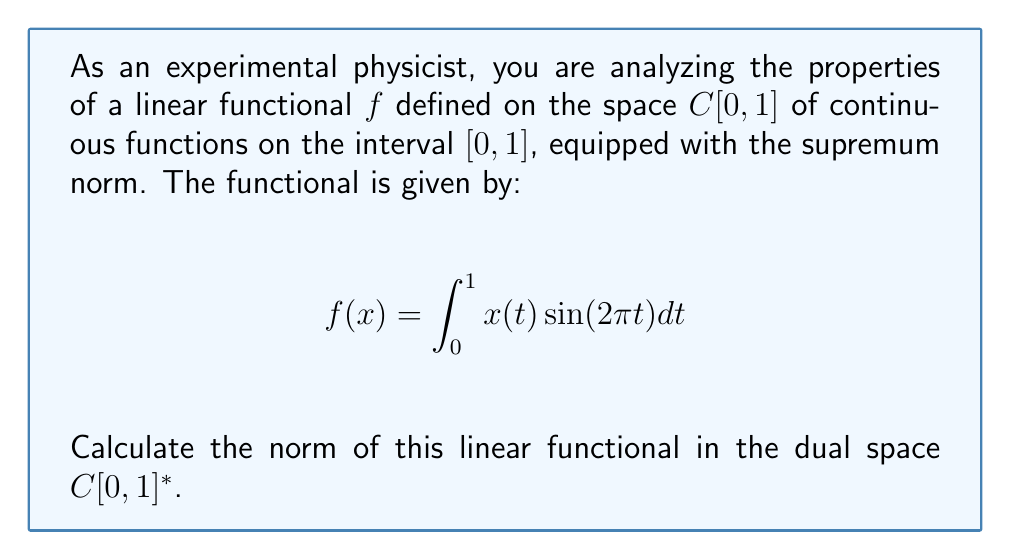Solve this math problem. To calculate the norm of the linear functional $f$ in the dual space $C[0,1]^*$, we need to follow these steps:

1) The norm of a linear functional $f$ in the dual space is defined as:

   $$\|f\| = \sup_{x \in C[0,1], \|x\| \leq 1} |f(x)|$$

2) For our specific functional:

   $$|f(x)| = \left|\int_0^1 x(t) \sin(2\pi t) dt\right|$$

3) We can apply the Cauchy-Schwarz inequality:

   $$|f(x)| \leq \int_0^1 |x(t)| |\sin(2\pi t)| dt$$

4) Since $\|x\| \leq 1$ in the supremum norm, we know that $|x(t)| \leq 1$ for all $t \in [0,1]$. Therefore:

   $$|f(x)| \leq \int_0^1 |\sin(2\pi t)| dt$$

5) This upper bound is actually achievable by choosing $x(t) = \text{sign}(\sin(2\pi t))$, which is within the unit ball of $C[0,1]$.

6) Therefore, the norm of $f$ is:

   $$\|f\| = \int_0^1 |\sin(2\pi t)| dt$$

7) This integral can be evaluated:

   $$\int_0^1 |\sin(2\pi t)| dt = \frac{2}{\pi}$$

Thus, we have found that the norm of the linear functional $f$ in $C[0,1]^*$ is $\frac{2}{\pi}$.
Answer: The norm of the linear functional $f$ in the dual space $C[0,1]^*$ is $\frac{2}{\pi}$. 